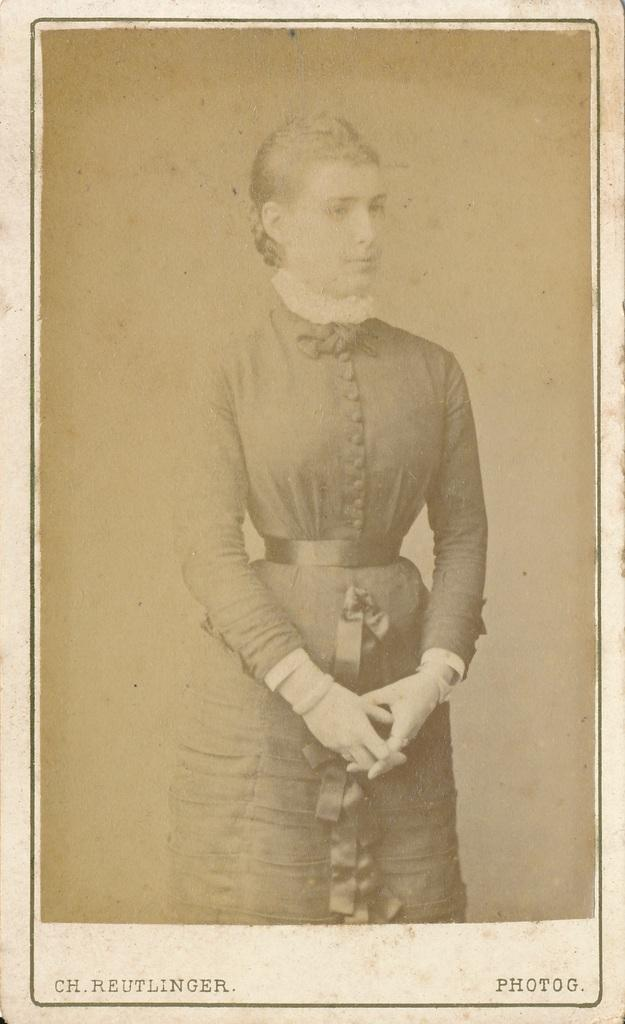What type of image is being described? The image is a photo. Can you describe the main subject in the photo? There is a person standing in the photo. Are there any additional elements in the photo besides the person? Yes, there are words on the photo. What type of zipper can be seen on the person's clothing in the photo? There is no zipper visible on the person's clothing in the photo. What news event is being discussed in the photo? The photo does not depict a news event or any discussion about news. 